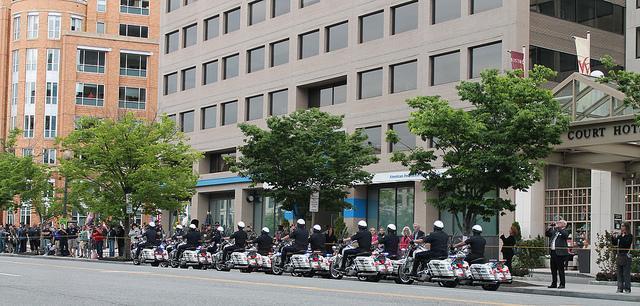How many trees can you see?
Give a very brief answer. 4. How many inches did it rain?
Give a very brief answer. 0. How many bicycles are in this scene?
Give a very brief answer. 0. 